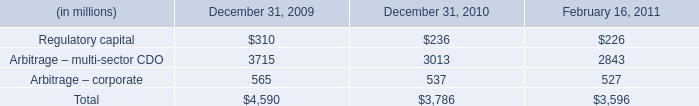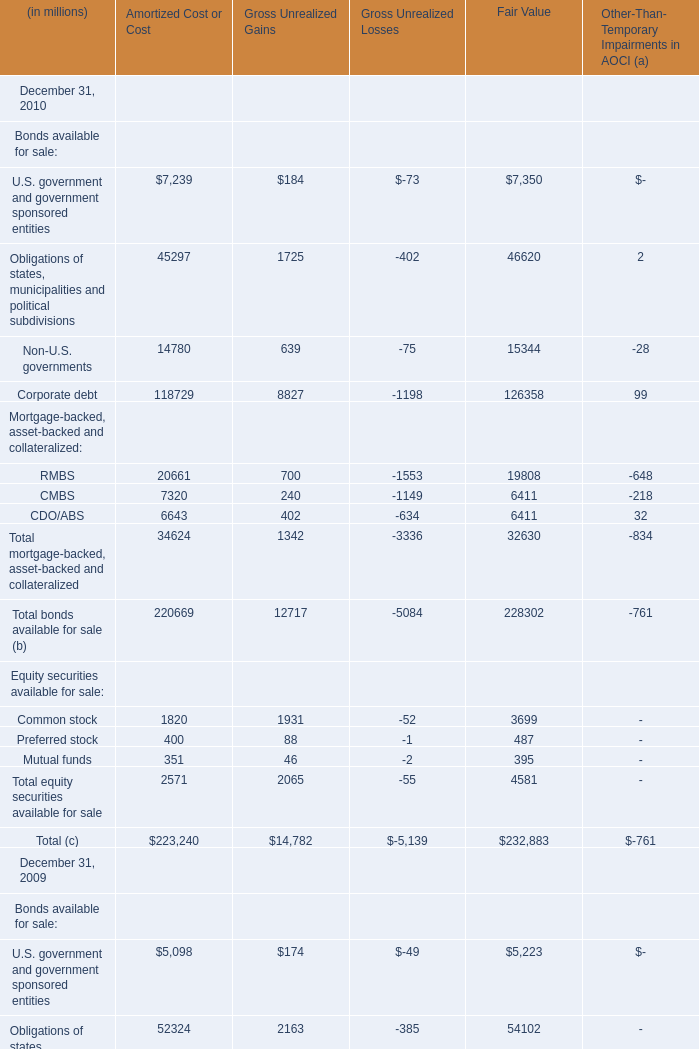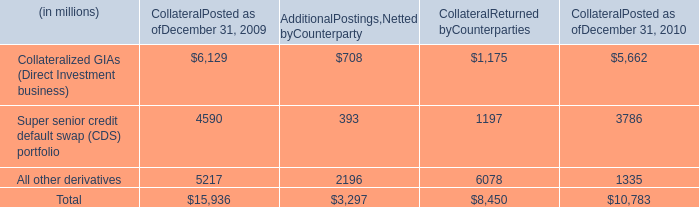What will RMBS of Amortized Cost or Cost be like in 2011 if it continues to grow at the same rate as it did in 2010? (in million) 
Computations: (20661 * (1 + ((20661 - 32173) / 32173)))
Answer: 13268.17272. 